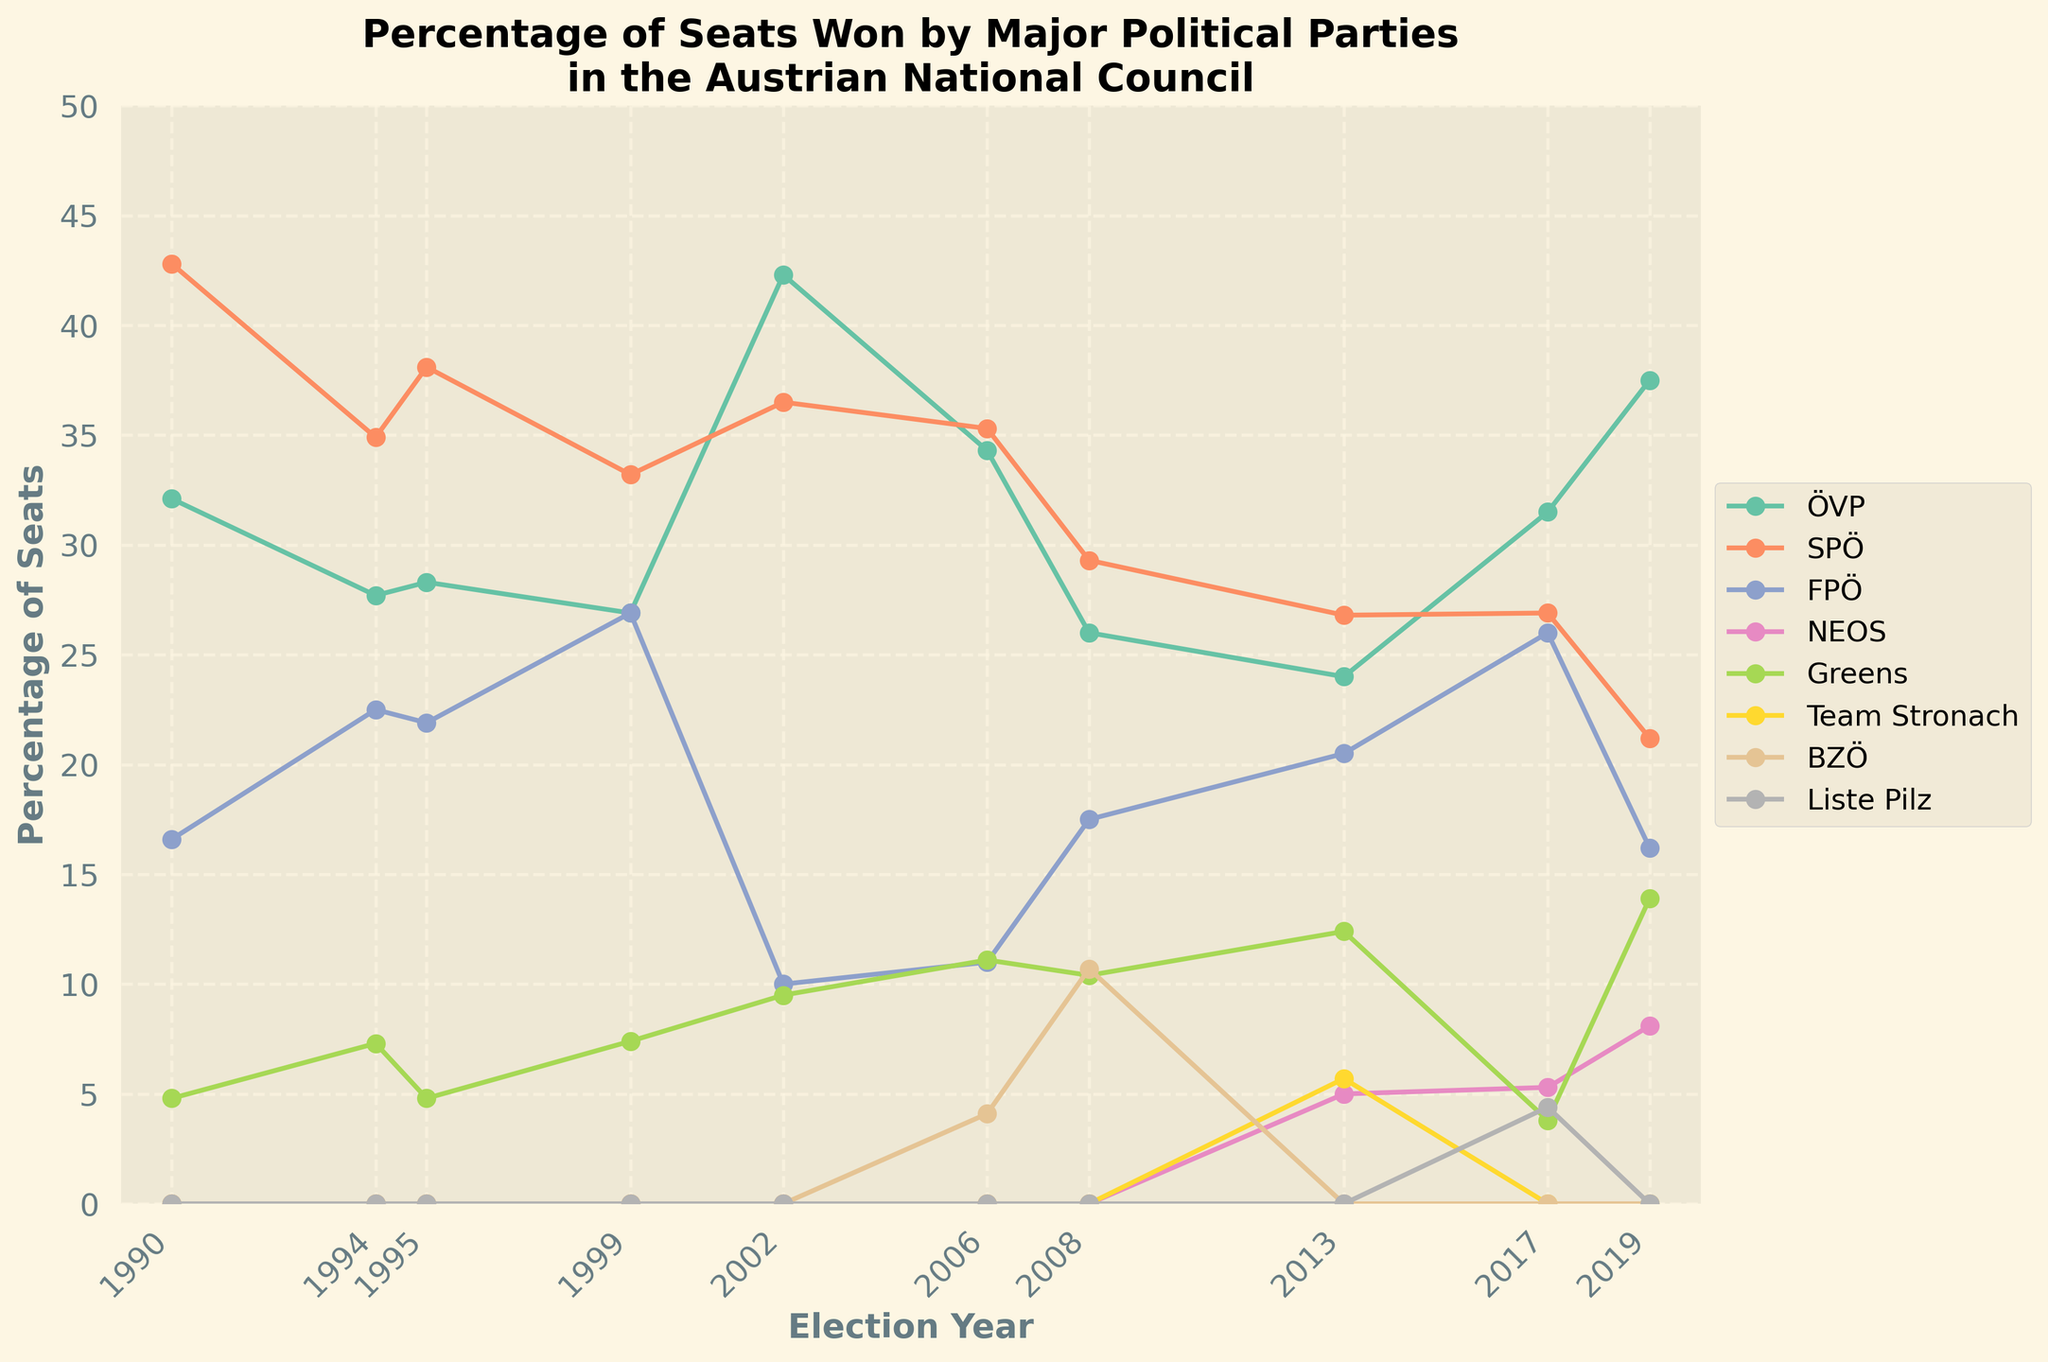Which party had the most significant decline in percentage of seats from 2017 to 2019? The figure shows the percentage of seats for all parties in both 2017 and 2019. Comparing these years, the SPÖ went from 26.9% to 21.2%, a decline of 5.7%. The FPÖ dropped from 26% to 16.2%, a decline of 9.8%. Thus, the FPÖ had the largest decline.
Answer: FPÖ Which party showed the most consistent performance over the last 10 elections? The most consistent party would be the one with least variation in the line plot over the years. The ÖVP and SPÖ lines are relatively more stable than others. The SPÖ shows less fluctuation compared to ÖVP.
Answer: SPÖ From 2006 to 2019, which party exhibited the largest overall increase in seats won? Comparing the starting percentage of seats from 2006 for each party to their percentages in 2019, only the ÖVP increased significantly, from 34.3% in 2006 to 37.5% in 2019, an increase of 3.2 percentage points.
Answer: ÖVP Which election year saw the highest combined percentage of seats for the FPÖ, NEOS, and Greens? We need to sum the percentages of FPÖ, NEOS, and Greens' seats for each election year and find the highest sum. 2019 has FPÖ (16.2%), NEOS (8.1%), and Greens (13.9%), totaling 38.2%.
Answer: 2019 Between 1999 and 2019, which party had the highest peak in the percentage of seats won, and in which year? Check the line plot for the highest percentage peak for each party between 1999 and 2019. The ÖVP in 2002 reached 42.3%, which is the highest peak for any party in this period.
Answer: ÖVP, 2002 Which minor parties (Team Stronach, BZÖ, Liste Pilz) managed to win any seats, and in which elections? Looking at the line plot for these three parties: 
- Team Stronach won seats in 2013 (5.7%),
- BZÖ won in 2006 (4.1%) and 2008 (10.7%),
- Liste Pilz won in 2017 (4.4%).
Answer: Team Stronach: 2013, BZÖ: 2006, 2008, Liste Pilz: 2017 How many times did the SPÖ secure more than 30% of the seats in the last 10 elections? Identify the points where SPÖ's plot line is above 30% within the given years. The SPÖ secured more than 30% in the years 1990 (42.8%), 1995 (38.1%), 1999 (33.2%), 2002 (36.5%), and 2006 (35.3%), totaling 5 times.
Answer: 5 In which elections did the Greens see a percentage of seats higher than 10%? Check the points where the Greens' line is above 10%. The Greens secured more than 10% in 1999 (7.4%) and 2008 (10.4%), 2013 (12.4%), and 2019 (13.9%).
Answer: 2008, 2013, 2019 